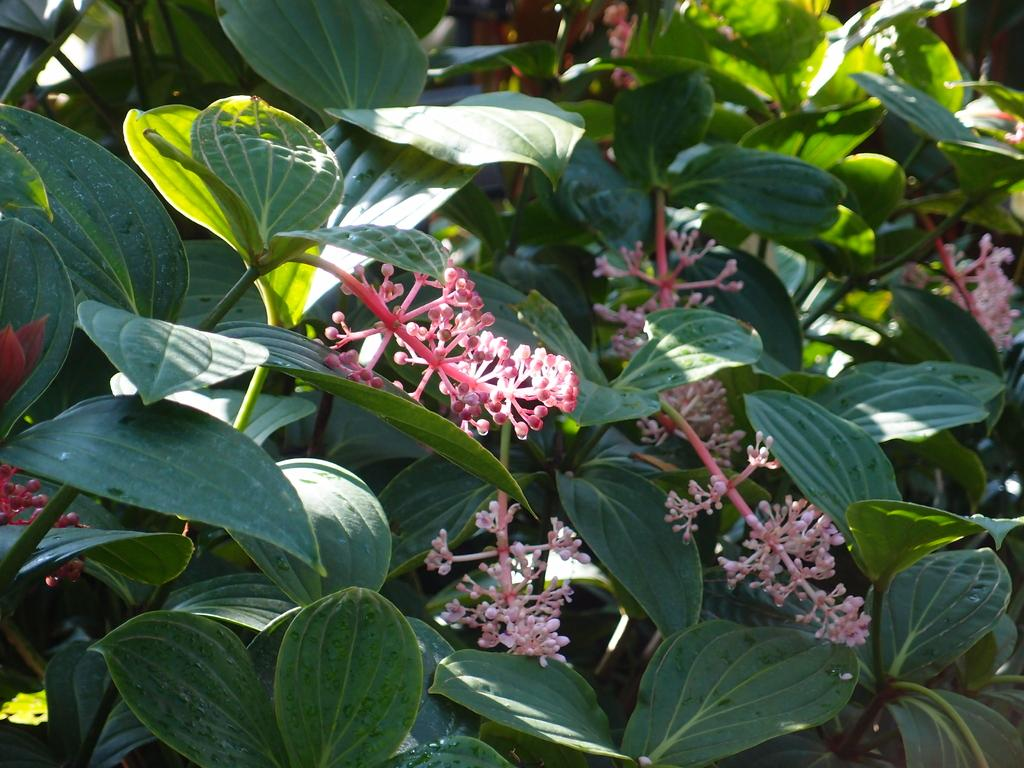What type of living organisms can be seen in the image? Plants and flowers are visible in the image. Can you describe the flowers in the image? The flowers are present in the image, but their specific characteristics are not mentioned in the provided facts. How many children are playing with the wax in the image? There are no children or wax present in the image. What type of crow can be seen interacting with the flowers in the image? There is no crow present in the image; only plants and flowers are mentioned. 